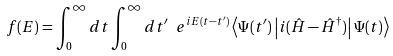Convert formula to latex. <formula><loc_0><loc_0><loc_500><loc_500>f ( E ) = \int _ { 0 } ^ { \infty } d t \int _ { 0 } ^ { \infty } d t ^ { \prime } \ e ^ { i E ( t - t ^ { \prime } ) } \left \langle \Psi ( t ^ { \prime } ) \left | i ( \hat { H } - \hat { H } ^ { \dag } ) \right | \Psi ( t ) \right \rangle</formula> 